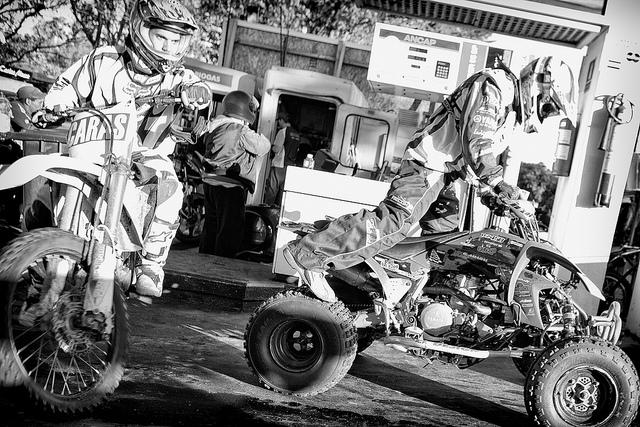Is anyone riding a motorcycle?
Quick response, please. Yes. Do both riders have head protection?
Answer briefly. Yes. Is the picture black and white?
Concise answer only. Yes. 